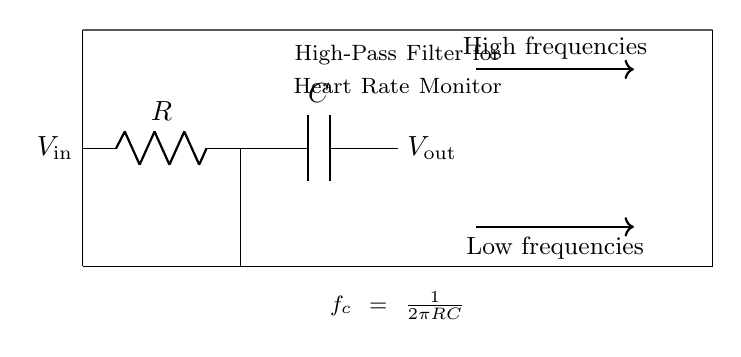What are the components used in this circuit? The circuit diagram clearly shows two main components: a resistor represented by R and a capacitor represented by C. These components are typical for a high-pass filter circuit.
Answer: Resistor and capacitor What does V_in represent in this circuit? V_in is marked at the left side of the circuit diagram and denotes the input voltage to the high-pass filter. It is the voltage provided to the circuit for processing the heart rate signals.
Answer: Input voltage What type of filter is illustrated in the circuit? The title within the circuit diagram specifies it as a "High-Pass Filter." Hence, it is a filter designed to allow high-frequency signals to pass through while attenuating low-frequency signals.
Answer: High-pass filter How is the cut-off frequency calculated in this circuit? The formula for cut-off frequency, fc = 1/(2πRC), is indicated in the circuit. This indicates that fc is determined by the values of resistance (R) and capacitance (C) in the circuit.
Answer: fc = 1/(2πRC) What is the direction of the signals passing through the filter? The arrows in the circuit diagram indicate that high frequencies are directed towards the output (V_out) while low frequencies are directed downwards, showing they are not passed through.
Answer: High frequencies to output What is represented by V_out in the diagram? V_out, located on the right side of the circuit, represents the output voltage of the high-pass filter, which reflects the processed signal after filtering out low frequencies.
Answer: Output voltage 